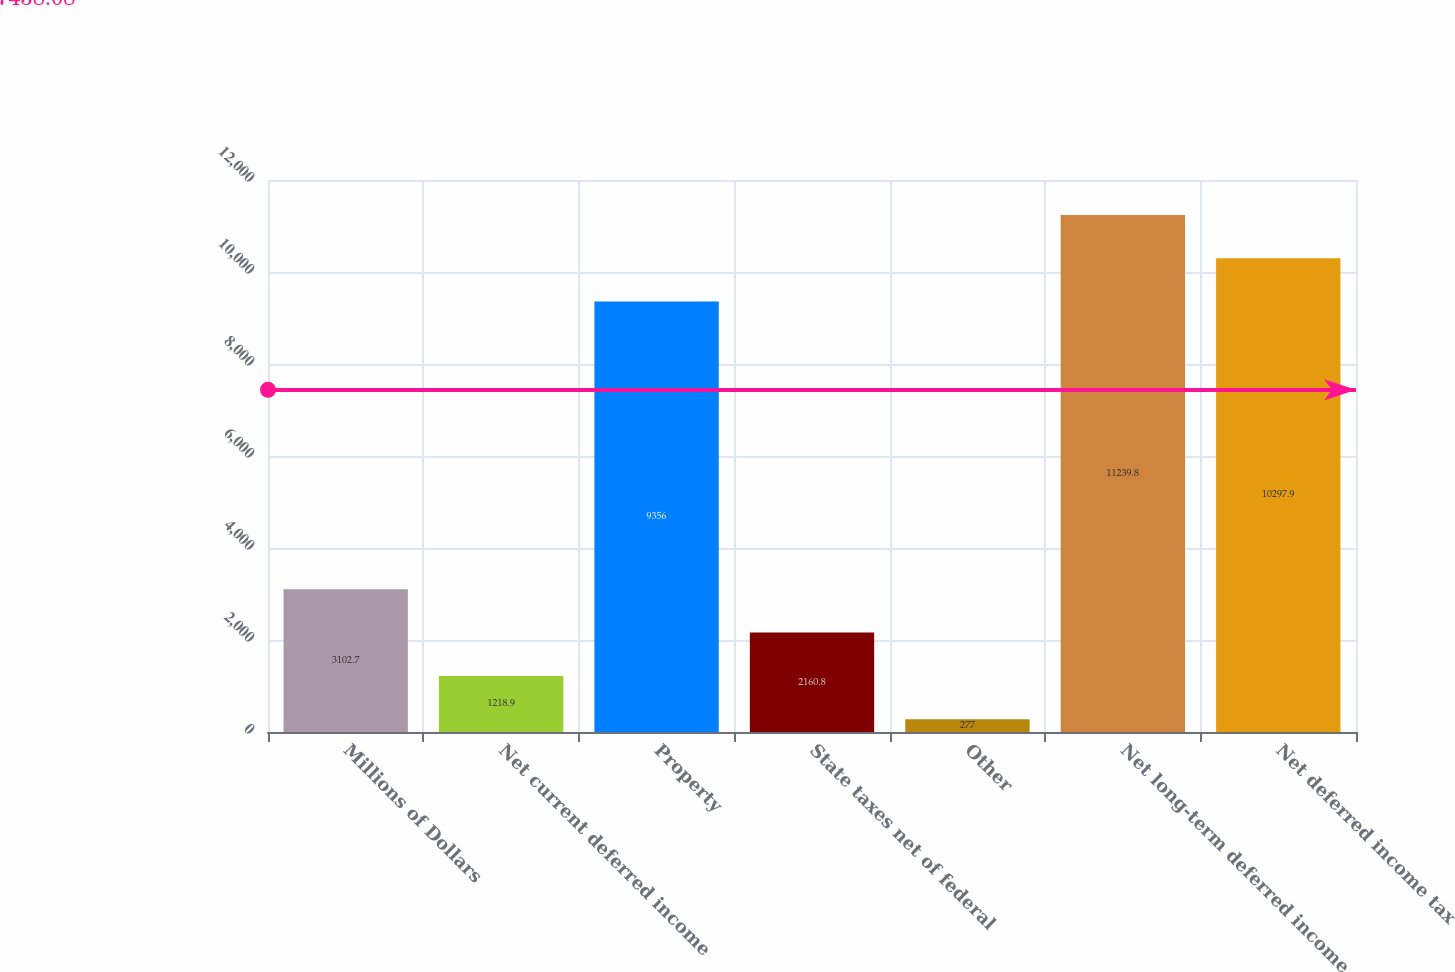<chart> <loc_0><loc_0><loc_500><loc_500><bar_chart><fcel>Millions of Dollars<fcel>Net current deferred income<fcel>Property<fcel>State taxes net of federal<fcel>Other<fcel>Net long-term deferred income<fcel>Net deferred income tax<nl><fcel>3102.7<fcel>1218.9<fcel>9356<fcel>2160.8<fcel>277<fcel>11239.8<fcel>10297.9<nl></chart> 